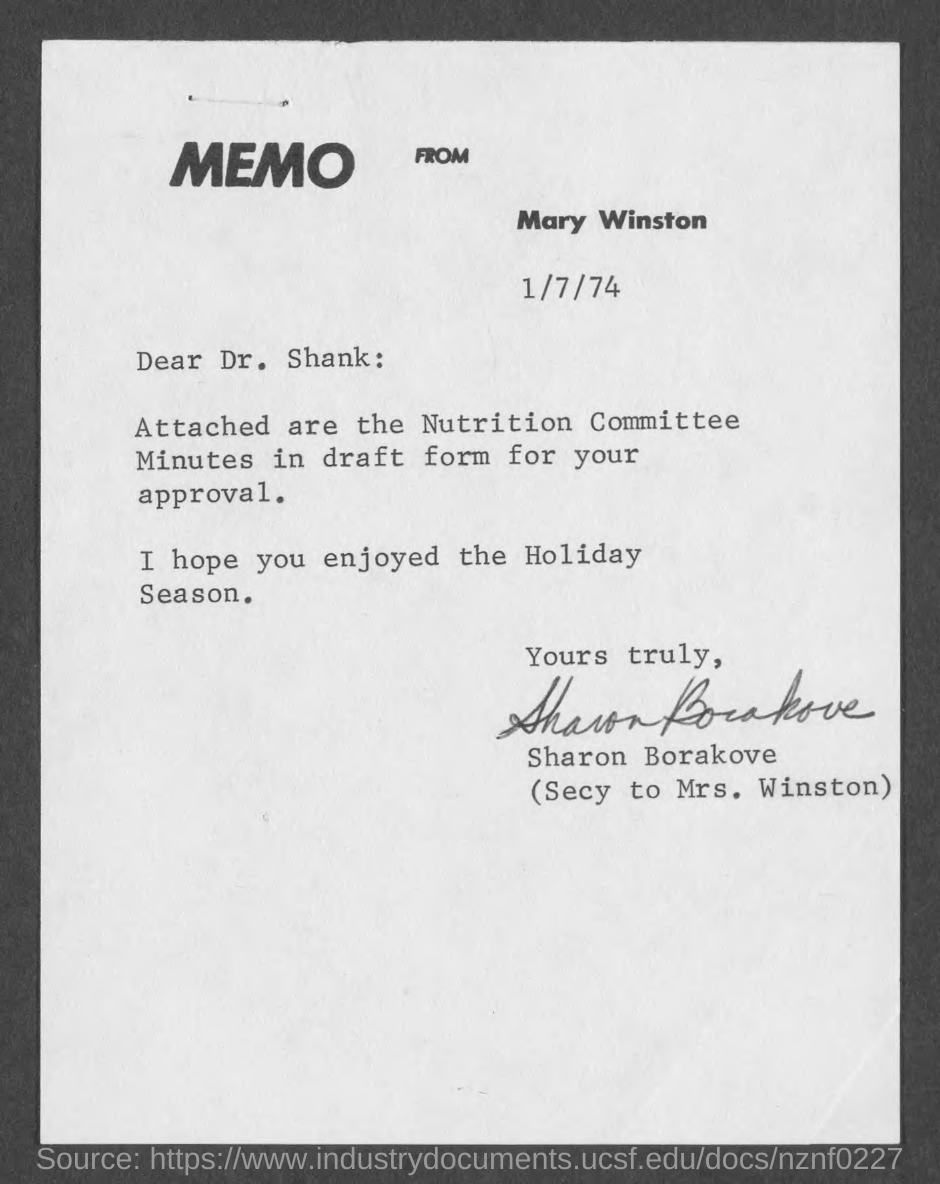What kind of communication is this ?
Provide a short and direct response. Memo. What is the date mentioned in the memo?
Give a very brief answer. 1/7/74. Who is the sender of this memo?
Provide a short and direct response. Mary Winston. Who has signed this memo?
Offer a terse response. Sharon Borakove. Who is the addressee of this memo?
Give a very brief answer. Dr. Shank. 